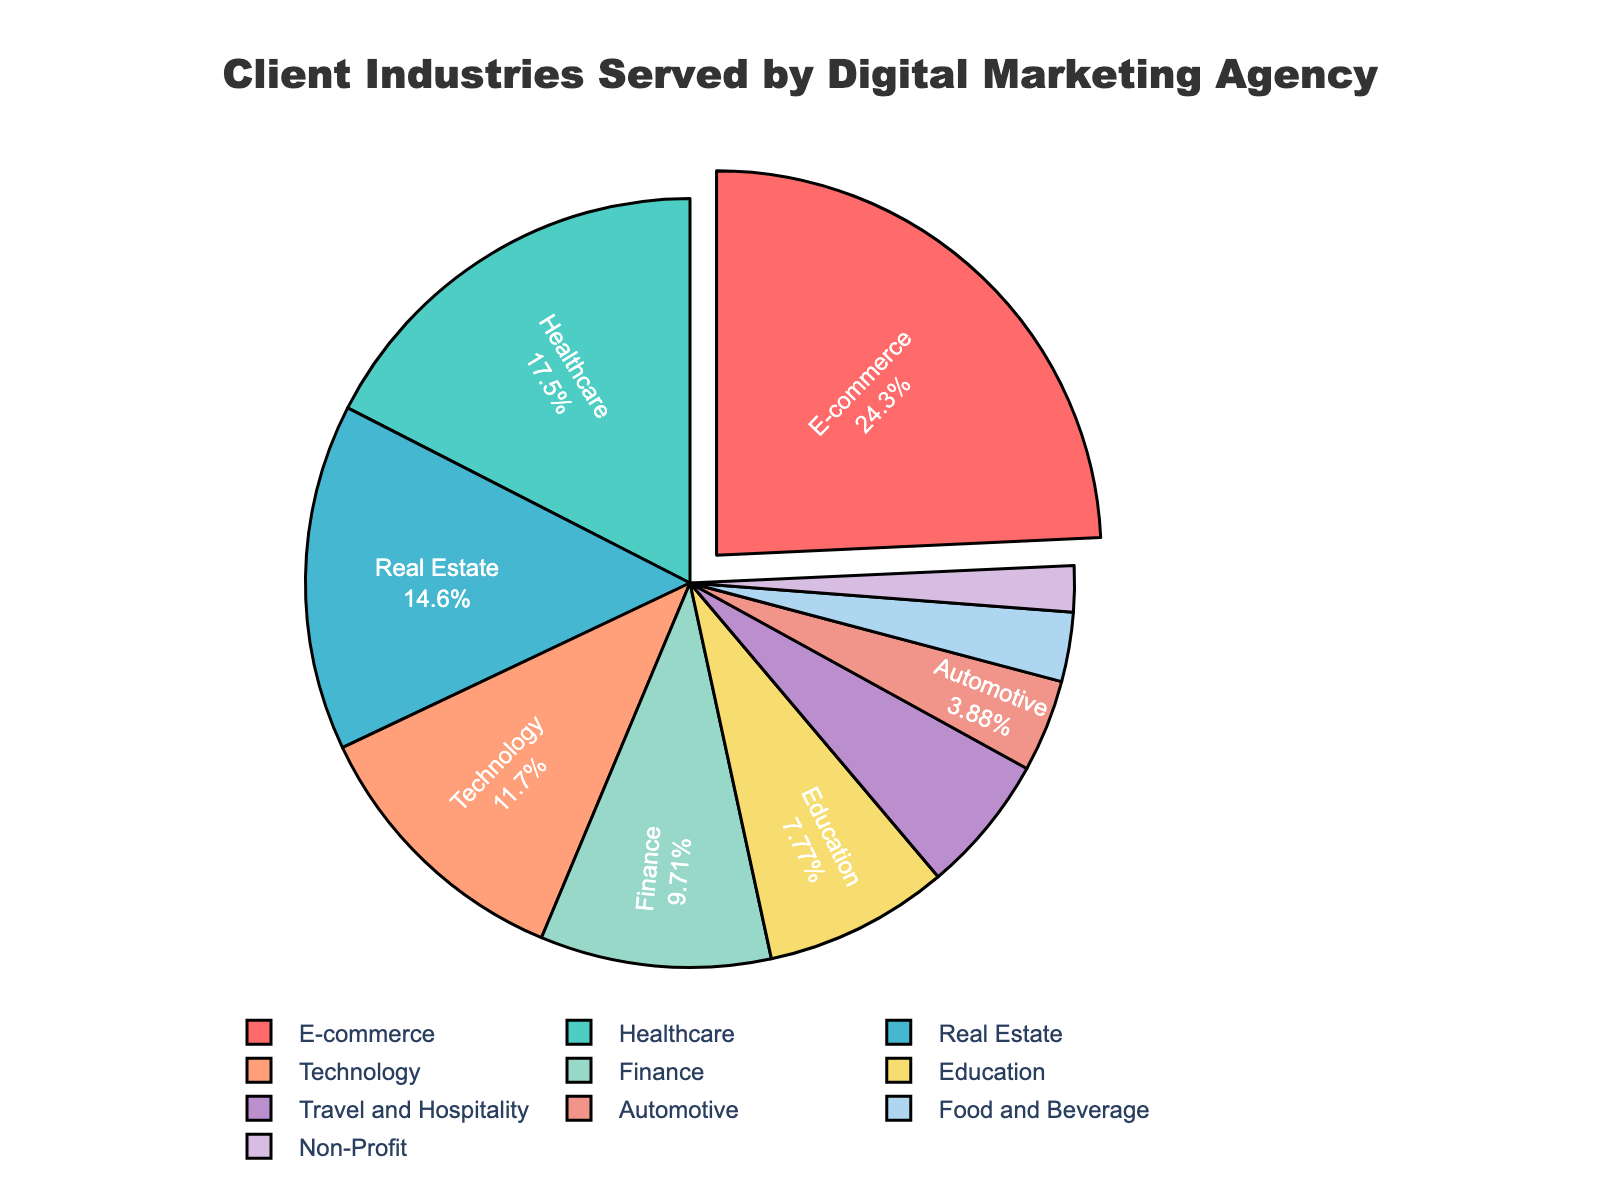What's the largest industry served by the digital marketing agency? The largest industry can be identified by looking at the slice of the pie chart with the highest percentage. The E-commerce sector accounts for 25%, which is the largest.
Answer: E-commerce Which two industries share the smallest proportion of clients? By examining the slices of the pie chart, the smallest proportions belong to Non-Profit at 2% and Food and Beverage at 3%.
Answer: Non-Profit and Food and Beverage How much larger is the percentage of clients in Healthcare compared to Technology? The percentage for Healthcare is 18%, and for Technology, it's 12%. Subtract 12 from 18 to find the difference: 18 - 12 = 6.
Answer: 6% What percentage of clients comes from the Finance and Real Estate industries combined? To find the combined percentage, add the percentages for Finance (10%) and Real Estate (15%): 10 + 15 = 25.
Answer: 25% Is the Travel and Hospitality sector more or less than half the size of the Education sector? The percentage for Education is 8%, and for Travel and Hospitality, it's 6%. Half of Education is 4%. Comparing 6% to 4%, Travel and Hospitality is larger.
Answer: More Which industry is represented by a green slice in the pie chart? The pie chart suggests the following color assignments by order of the data: E-commerce (red), Healthcare (green).
Answer: Healthcare How does the combined proportion of Automotive and Non-Profit clients compare to the Technology sector? Add Automotive (4%) and Non-Profit (2%) to get a combined percentage: 4 + 2 = 6. Technology accounts for 12%, which is larger than 6%.
Answer: Less What's the difference in percentage between the largest and smallest sectors? The percentage for the largest sector (E-commerce) is 25%, and the smallest (Non-Profit) is 2%. Subtract 2 from 25 to find the difference: 25 - 2 = 23.
Answer: 23% What is the second largest industry served, according to the pie chart? By examining the pie chart, the second largest slice after E-commerce (25%) is Healthcare (18%).
Answer: Healthcare Which industries have a larger percentage of clients than the Technology sector? Technology accounts for 12%. The industries with larger percentages are E-commerce (25%), Healthcare (18%), and Real Estate (15%).
Answer: E-commerce, Healthcare, Real Estate 